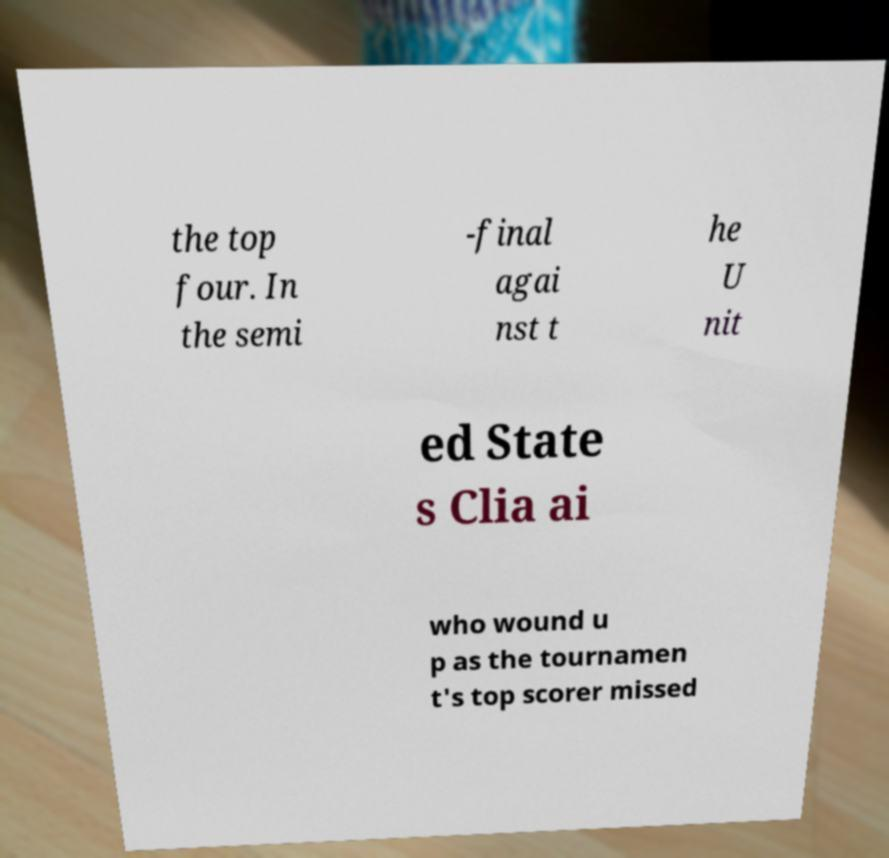For documentation purposes, I need the text within this image transcribed. Could you provide that? the top four. In the semi -final agai nst t he U nit ed State s Clia ai who wound u p as the tournamen t's top scorer missed 